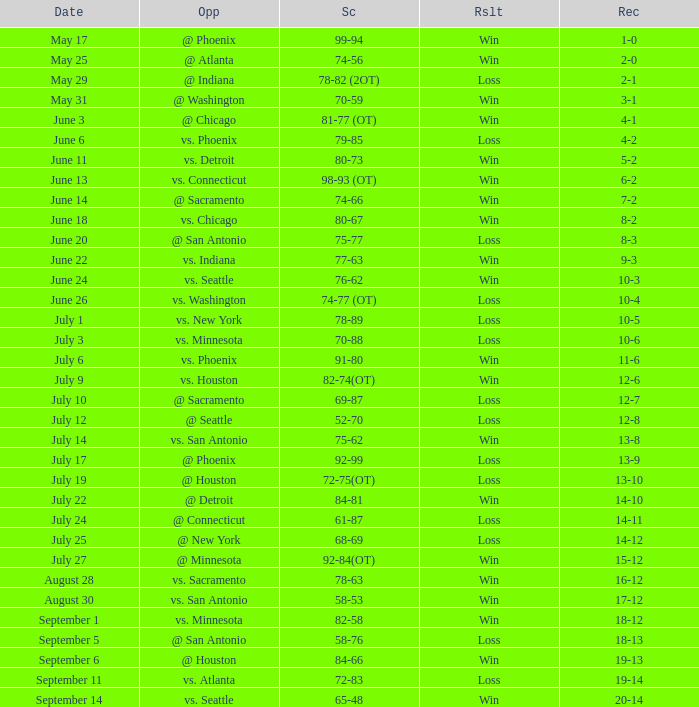What is the Opponent of the game with a Score of 74-66? @ Sacramento. 